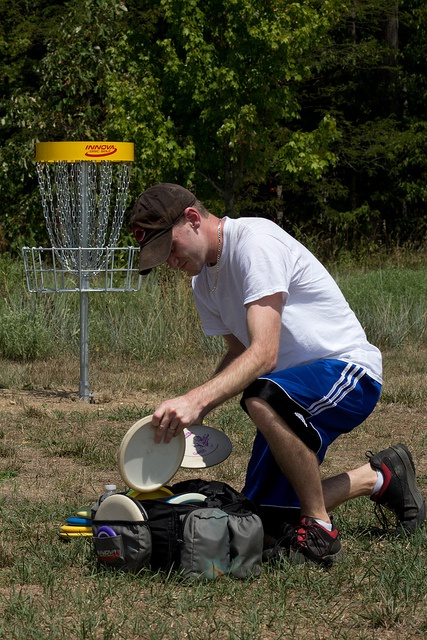Describe the objects in this image and their specific colors. I can see people in darkgreen, black, lavender, gray, and maroon tones, backpack in darkgreen, black, gray, and darkgray tones, frisbee in darkgreen, gray, and darkgray tones, frisbee in darkgreen, gray, beige, and black tones, and frisbee in darkgreen, gray, darkgray, and black tones in this image. 